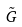Convert formula to latex. <formula><loc_0><loc_0><loc_500><loc_500>\tilde { G }</formula> 